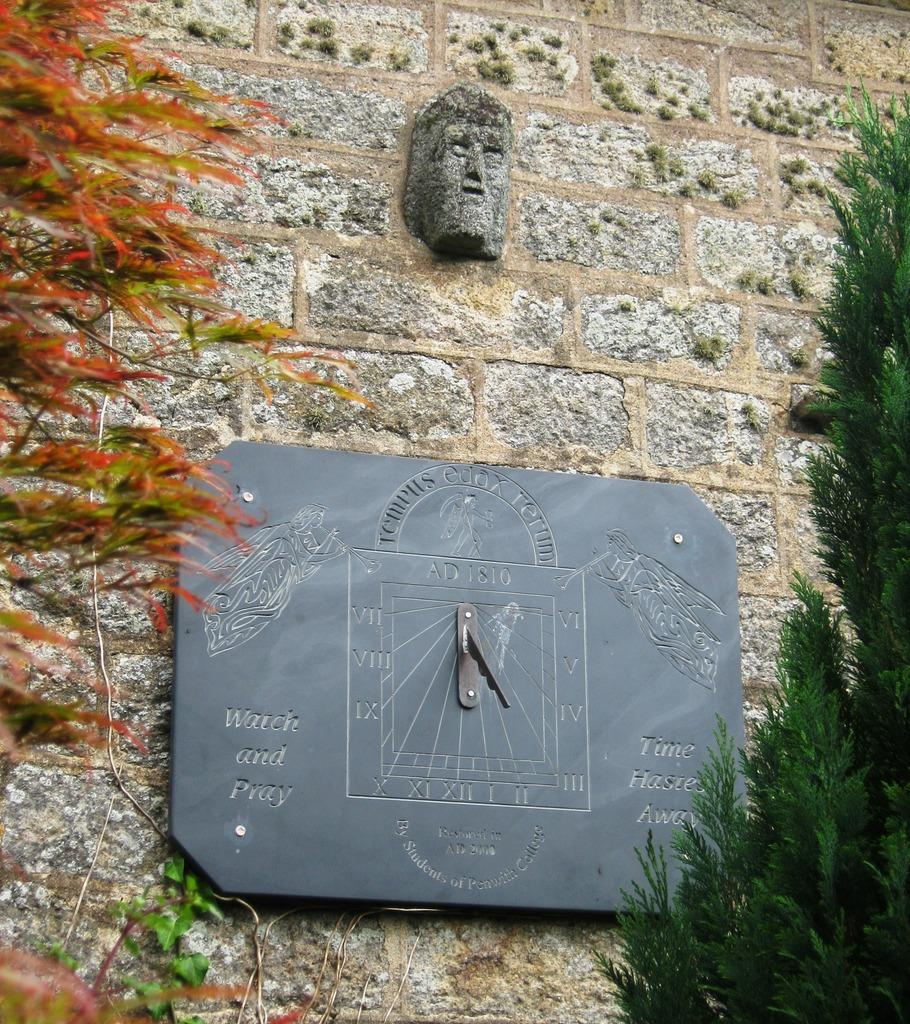What type of natural elements can be seen in the image? There are trees in the image. What man-made object is present in the image? There is a carved clock in the image. Can you describe the clock in more detail? The clock has text and a design on it. What other carved object can be seen in the image? There is a carved stone on the wall in the image. What type of joke is being told by the carriage in the image? There is no carriage present in the image, so no joke can be told by it. 